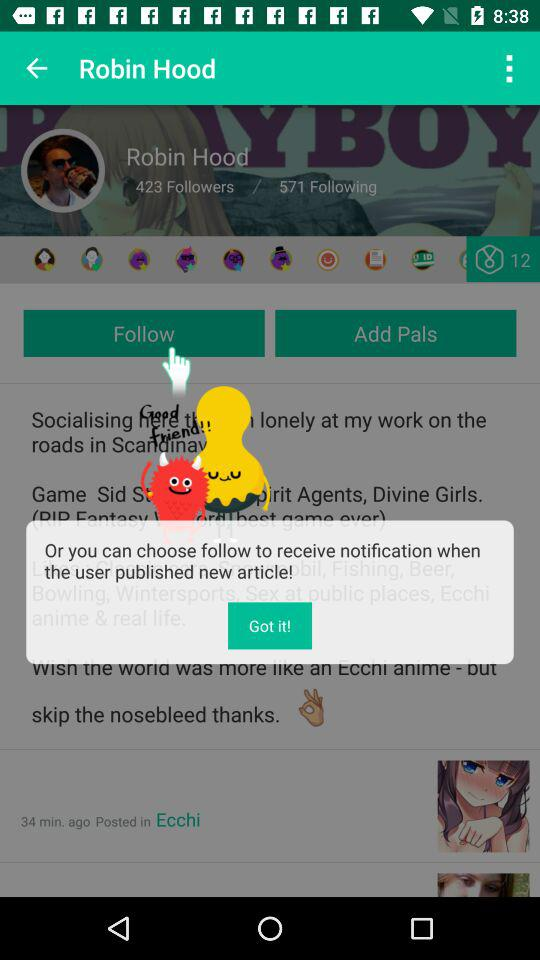How many followers does Robin Hood have? Robin Hood has 423 followers. 